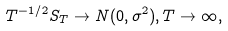<formula> <loc_0><loc_0><loc_500><loc_500>T ^ { - 1 / 2 } S _ { T } \rightarrow N ( 0 , \sigma ^ { 2 } ) , T \rightarrow \infty ,</formula> 